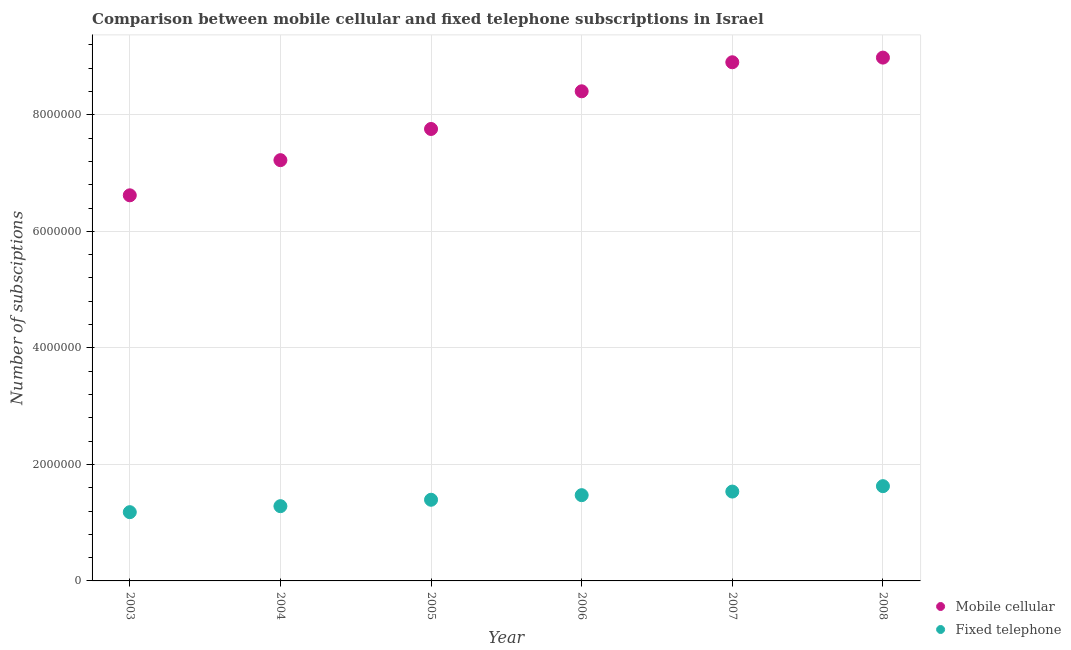What is the number of fixed telephone subscriptions in 2006?
Provide a short and direct response. 1.47e+06. Across all years, what is the maximum number of mobile cellular subscriptions?
Your response must be concise. 8.98e+06. Across all years, what is the minimum number of fixed telephone subscriptions?
Your response must be concise. 1.18e+06. In which year was the number of fixed telephone subscriptions minimum?
Give a very brief answer. 2003. What is the total number of mobile cellular subscriptions in the graph?
Your response must be concise. 4.79e+07. What is the difference between the number of mobile cellular subscriptions in 2003 and that in 2005?
Ensure brevity in your answer.  -1.14e+06. What is the difference between the number of fixed telephone subscriptions in 2006 and the number of mobile cellular subscriptions in 2005?
Provide a succinct answer. -6.29e+06. What is the average number of mobile cellular subscriptions per year?
Make the answer very short. 7.98e+06. In the year 2004, what is the difference between the number of fixed telephone subscriptions and number of mobile cellular subscriptions?
Keep it short and to the point. -5.94e+06. What is the ratio of the number of fixed telephone subscriptions in 2003 to that in 2008?
Make the answer very short. 0.73. Is the number of mobile cellular subscriptions in 2004 less than that in 2007?
Ensure brevity in your answer.  Yes. What is the difference between the highest and the lowest number of fixed telephone subscriptions?
Provide a succinct answer. 4.46e+05. Does the number of fixed telephone subscriptions monotonically increase over the years?
Ensure brevity in your answer.  Yes. How many dotlines are there?
Offer a terse response. 2. How many years are there in the graph?
Your response must be concise. 6. Are the values on the major ticks of Y-axis written in scientific E-notation?
Ensure brevity in your answer.  No. Does the graph contain grids?
Keep it short and to the point. Yes. How are the legend labels stacked?
Your answer should be very brief. Vertical. What is the title of the graph?
Your answer should be very brief. Comparison between mobile cellular and fixed telephone subscriptions in Israel. Does "Electricity" appear as one of the legend labels in the graph?
Ensure brevity in your answer.  No. What is the label or title of the X-axis?
Provide a succinct answer. Year. What is the label or title of the Y-axis?
Make the answer very short. Number of subsciptions. What is the Number of subsciptions of Mobile cellular in 2003?
Keep it short and to the point. 6.62e+06. What is the Number of subsciptions of Fixed telephone in 2003?
Ensure brevity in your answer.  1.18e+06. What is the Number of subsciptions in Mobile cellular in 2004?
Your answer should be very brief. 7.22e+06. What is the Number of subsciptions in Fixed telephone in 2004?
Provide a short and direct response. 1.28e+06. What is the Number of subsciptions of Mobile cellular in 2005?
Your answer should be compact. 7.76e+06. What is the Number of subsciptions in Fixed telephone in 2005?
Offer a very short reply. 1.39e+06. What is the Number of subsciptions in Mobile cellular in 2006?
Give a very brief answer. 8.40e+06. What is the Number of subsciptions of Fixed telephone in 2006?
Offer a very short reply. 1.47e+06. What is the Number of subsciptions of Mobile cellular in 2007?
Give a very brief answer. 8.90e+06. What is the Number of subsciptions in Fixed telephone in 2007?
Your response must be concise. 1.53e+06. What is the Number of subsciptions of Mobile cellular in 2008?
Your answer should be very brief. 8.98e+06. What is the Number of subsciptions in Fixed telephone in 2008?
Provide a short and direct response. 1.63e+06. Across all years, what is the maximum Number of subsciptions in Mobile cellular?
Offer a very short reply. 8.98e+06. Across all years, what is the maximum Number of subsciptions of Fixed telephone?
Your answer should be very brief. 1.63e+06. Across all years, what is the minimum Number of subsciptions in Mobile cellular?
Give a very brief answer. 6.62e+06. Across all years, what is the minimum Number of subsciptions of Fixed telephone?
Offer a very short reply. 1.18e+06. What is the total Number of subsciptions in Mobile cellular in the graph?
Ensure brevity in your answer.  4.79e+07. What is the total Number of subsciptions in Fixed telephone in the graph?
Make the answer very short. 8.49e+06. What is the difference between the Number of subsciptions of Mobile cellular in 2003 and that in 2004?
Ensure brevity in your answer.  -6.04e+05. What is the difference between the Number of subsciptions in Fixed telephone in 2003 and that in 2004?
Offer a terse response. -1.03e+05. What is the difference between the Number of subsciptions of Mobile cellular in 2003 and that in 2005?
Your answer should be very brief. -1.14e+06. What is the difference between the Number of subsciptions of Fixed telephone in 2003 and that in 2005?
Ensure brevity in your answer.  -2.13e+05. What is the difference between the Number of subsciptions in Mobile cellular in 2003 and that in 2006?
Make the answer very short. -1.79e+06. What is the difference between the Number of subsciptions of Fixed telephone in 2003 and that in 2006?
Provide a short and direct response. -2.92e+05. What is the difference between the Number of subsciptions of Mobile cellular in 2003 and that in 2007?
Provide a succinct answer. -2.28e+06. What is the difference between the Number of subsciptions of Fixed telephone in 2003 and that in 2007?
Your response must be concise. -3.54e+05. What is the difference between the Number of subsciptions in Mobile cellular in 2003 and that in 2008?
Provide a succinct answer. -2.36e+06. What is the difference between the Number of subsciptions of Fixed telephone in 2003 and that in 2008?
Offer a terse response. -4.46e+05. What is the difference between the Number of subsciptions of Mobile cellular in 2004 and that in 2005?
Provide a succinct answer. -5.35e+05. What is the difference between the Number of subsciptions in Mobile cellular in 2004 and that in 2006?
Your answer should be compact. -1.18e+06. What is the difference between the Number of subsciptions of Fixed telephone in 2004 and that in 2006?
Your answer should be very brief. -1.89e+05. What is the difference between the Number of subsciptions in Mobile cellular in 2004 and that in 2007?
Keep it short and to the point. -1.68e+06. What is the difference between the Number of subsciptions in Fixed telephone in 2004 and that in 2007?
Provide a short and direct response. -2.51e+05. What is the difference between the Number of subsciptions in Mobile cellular in 2004 and that in 2008?
Give a very brief answer. -1.76e+06. What is the difference between the Number of subsciptions in Fixed telephone in 2004 and that in 2008?
Your answer should be very brief. -3.43e+05. What is the difference between the Number of subsciptions of Mobile cellular in 2005 and that in 2006?
Offer a very short reply. -6.47e+05. What is the difference between the Number of subsciptions in Fixed telephone in 2005 and that in 2006?
Ensure brevity in your answer.  -7.89e+04. What is the difference between the Number of subsciptions of Mobile cellular in 2005 and that in 2007?
Keep it short and to the point. -1.14e+06. What is the difference between the Number of subsciptions in Fixed telephone in 2005 and that in 2007?
Provide a short and direct response. -1.41e+05. What is the difference between the Number of subsciptions in Mobile cellular in 2005 and that in 2008?
Provide a short and direct response. -1.22e+06. What is the difference between the Number of subsciptions of Fixed telephone in 2005 and that in 2008?
Your answer should be compact. -2.33e+05. What is the difference between the Number of subsciptions of Mobile cellular in 2006 and that in 2007?
Provide a short and direct response. -4.98e+05. What is the difference between the Number of subsciptions of Fixed telephone in 2006 and that in 2007?
Your response must be concise. -6.17e+04. What is the difference between the Number of subsciptions in Mobile cellular in 2006 and that in 2008?
Your answer should be compact. -5.78e+05. What is the difference between the Number of subsciptions in Fixed telephone in 2006 and that in 2008?
Ensure brevity in your answer.  -1.55e+05. What is the difference between the Number of subsciptions of Fixed telephone in 2007 and that in 2008?
Make the answer very short. -9.29e+04. What is the difference between the Number of subsciptions of Mobile cellular in 2003 and the Number of subsciptions of Fixed telephone in 2004?
Your answer should be very brief. 5.34e+06. What is the difference between the Number of subsciptions in Mobile cellular in 2003 and the Number of subsciptions in Fixed telephone in 2005?
Make the answer very short. 5.23e+06. What is the difference between the Number of subsciptions of Mobile cellular in 2003 and the Number of subsciptions of Fixed telephone in 2006?
Offer a very short reply. 5.15e+06. What is the difference between the Number of subsciptions in Mobile cellular in 2003 and the Number of subsciptions in Fixed telephone in 2007?
Offer a terse response. 5.08e+06. What is the difference between the Number of subsciptions of Mobile cellular in 2003 and the Number of subsciptions of Fixed telephone in 2008?
Keep it short and to the point. 4.99e+06. What is the difference between the Number of subsciptions in Mobile cellular in 2004 and the Number of subsciptions in Fixed telephone in 2005?
Provide a short and direct response. 5.83e+06. What is the difference between the Number of subsciptions in Mobile cellular in 2004 and the Number of subsciptions in Fixed telephone in 2006?
Your response must be concise. 5.75e+06. What is the difference between the Number of subsciptions of Mobile cellular in 2004 and the Number of subsciptions of Fixed telephone in 2007?
Make the answer very short. 5.69e+06. What is the difference between the Number of subsciptions in Mobile cellular in 2004 and the Number of subsciptions in Fixed telephone in 2008?
Offer a very short reply. 5.60e+06. What is the difference between the Number of subsciptions in Mobile cellular in 2005 and the Number of subsciptions in Fixed telephone in 2006?
Your answer should be compact. 6.29e+06. What is the difference between the Number of subsciptions in Mobile cellular in 2005 and the Number of subsciptions in Fixed telephone in 2007?
Your answer should be very brief. 6.22e+06. What is the difference between the Number of subsciptions of Mobile cellular in 2005 and the Number of subsciptions of Fixed telephone in 2008?
Your answer should be very brief. 6.13e+06. What is the difference between the Number of subsciptions of Mobile cellular in 2006 and the Number of subsciptions of Fixed telephone in 2007?
Offer a very short reply. 6.87e+06. What is the difference between the Number of subsciptions of Mobile cellular in 2006 and the Number of subsciptions of Fixed telephone in 2008?
Ensure brevity in your answer.  6.78e+06. What is the difference between the Number of subsciptions in Mobile cellular in 2007 and the Number of subsciptions in Fixed telephone in 2008?
Provide a succinct answer. 7.28e+06. What is the average Number of subsciptions of Mobile cellular per year?
Provide a short and direct response. 7.98e+06. What is the average Number of subsciptions in Fixed telephone per year?
Offer a terse response. 1.41e+06. In the year 2003, what is the difference between the Number of subsciptions of Mobile cellular and Number of subsciptions of Fixed telephone?
Your answer should be compact. 5.44e+06. In the year 2004, what is the difference between the Number of subsciptions of Mobile cellular and Number of subsciptions of Fixed telephone?
Make the answer very short. 5.94e+06. In the year 2005, what is the difference between the Number of subsciptions of Mobile cellular and Number of subsciptions of Fixed telephone?
Your answer should be compact. 6.36e+06. In the year 2006, what is the difference between the Number of subsciptions of Mobile cellular and Number of subsciptions of Fixed telephone?
Provide a short and direct response. 6.93e+06. In the year 2007, what is the difference between the Number of subsciptions in Mobile cellular and Number of subsciptions in Fixed telephone?
Provide a succinct answer. 7.37e+06. In the year 2008, what is the difference between the Number of subsciptions in Mobile cellular and Number of subsciptions in Fixed telephone?
Give a very brief answer. 7.36e+06. What is the ratio of the Number of subsciptions of Mobile cellular in 2003 to that in 2004?
Ensure brevity in your answer.  0.92. What is the ratio of the Number of subsciptions of Fixed telephone in 2003 to that in 2004?
Your response must be concise. 0.92. What is the ratio of the Number of subsciptions in Mobile cellular in 2003 to that in 2005?
Keep it short and to the point. 0.85. What is the ratio of the Number of subsciptions in Fixed telephone in 2003 to that in 2005?
Your answer should be compact. 0.85. What is the ratio of the Number of subsciptions of Mobile cellular in 2003 to that in 2006?
Make the answer very short. 0.79. What is the ratio of the Number of subsciptions of Fixed telephone in 2003 to that in 2006?
Keep it short and to the point. 0.8. What is the ratio of the Number of subsciptions of Mobile cellular in 2003 to that in 2007?
Ensure brevity in your answer.  0.74. What is the ratio of the Number of subsciptions of Fixed telephone in 2003 to that in 2007?
Offer a very short reply. 0.77. What is the ratio of the Number of subsciptions of Mobile cellular in 2003 to that in 2008?
Your response must be concise. 0.74. What is the ratio of the Number of subsciptions of Fixed telephone in 2003 to that in 2008?
Keep it short and to the point. 0.73. What is the ratio of the Number of subsciptions in Fixed telephone in 2004 to that in 2005?
Give a very brief answer. 0.92. What is the ratio of the Number of subsciptions of Mobile cellular in 2004 to that in 2006?
Keep it short and to the point. 0.86. What is the ratio of the Number of subsciptions in Fixed telephone in 2004 to that in 2006?
Ensure brevity in your answer.  0.87. What is the ratio of the Number of subsciptions of Mobile cellular in 2004 to that in 2007?
Provide a short and direct response. 0.81. What is the ratio of the Number of subsciptions of Fixed telephone in 2004 to that in 2007?
Offer a very short reply. 0.84. What is the ratio of the Number of subsciptions of Mobile cellular in 2004 to that in 2008?
Provide a succinct answer. 0.8. What is the ratio of the Number of subsciptions in Fixed telephone in 2004 to that in 2008?
Your answer should be very brief. 0.79. What is the ratio of the Number of subsciptions of Mobile cellular in 2005 to that in 2006?
Offer a very short reply. 0.92. What is the ratio of the Number of subsciptions of Fixed telephone in 2005 to that in 2006?
Your response must be concise. 0.95. What is the ratio of the Number of subsciptions in Mobile cellular in 2005 to that in 2007?
Ensure brevity in your answer.  0.87. What is the ratio of the Number of subsciptions of Fixed telephone in 2005 to that in 2007?
Provide a short and direct response. 0.91. What is the ratio of the Number of subsciptions in Mobile cellular in 2005 to that in 2008?
Keep it short and to the point. 0.86. What is the ratio of the Number of subsciptions of Fixed telephone in 2005 to that in 2008?
Make the answer very short. 0.86. What is the ratio of the Number of subsciptions of Mobile cellular in 2006 to that in 2007?
Provide a short and direct response. 0.94. What is the ratio of the Number of subsciptions of Fixed telephone in 2006 to that in 2007?
Your answer should be very brief. 0.96. What is the ratio of the Number of subsciptions in Mobile cellular in 2006 to that in 2008?
Your answer should be very brief. 0.94. What is the ratio of the Number of subsciptions of Fixed telephone in 2006 to that in 2008?
Keep it short and to the point. 0.91. What is the ratio of the Number of subsciptions in Mobile cellular in 2007 to that in 2008?
Offer a very short reply. 0.99. What is the ratio of the Number of subsciptions of Fixed telephone in 2007 to that in 2008?
Make the answer very short. 0.94. What is the difference between the highest and the second highest Number of subsciptions in Fixed telephone?
Provide a short and direct response. 9.29e+04. What is the difference between the highest and the lowest Number of subsciptions in Mobile cellular?
Your response must be concise. 2.36e+06. What is the difference between the highest and the lowest Number of subsciptions of Fixed telephone?
Ensure brevity in your answer.  4.46e+05. 